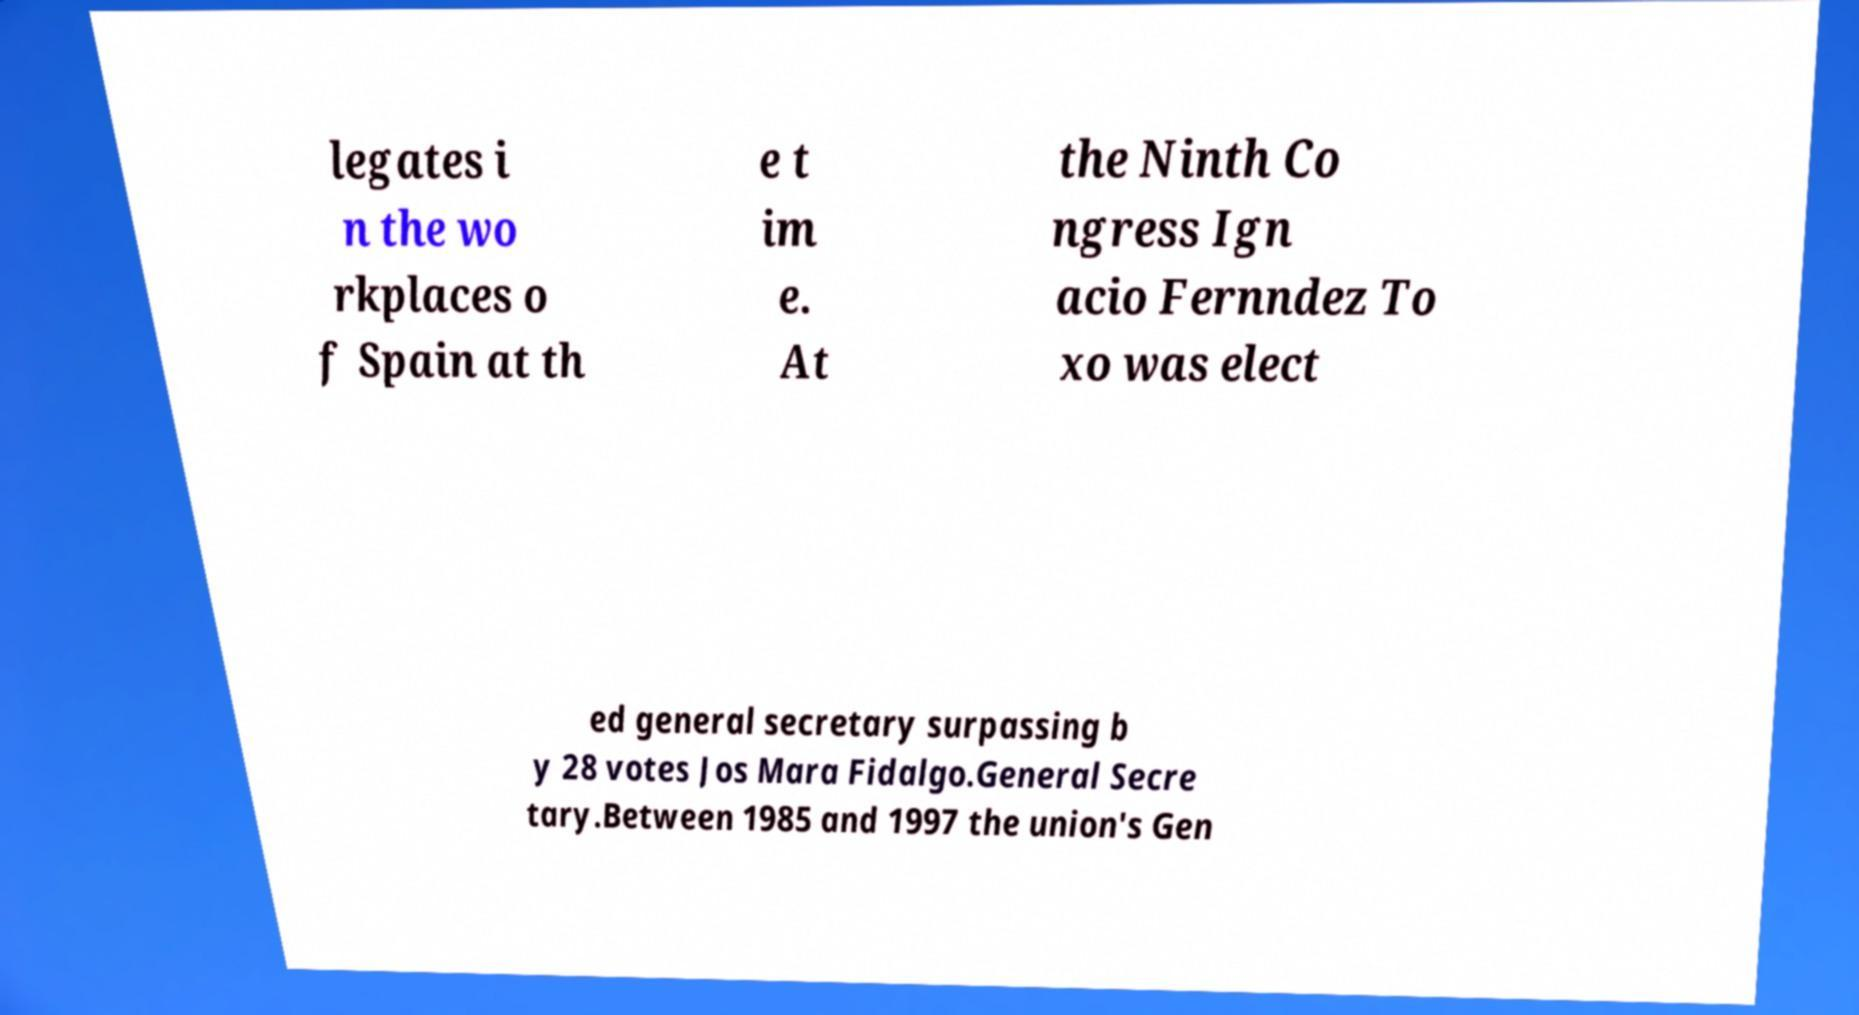Could you assist in decoding the text presented in this image and type it out clearly? legates i n the wo rkplaces o f Spain at th e t im e. At the Ninth Co ngress Ign acio Fernndez To xo was elect ed general secretary surpassing b y 28 votes Jos Mara Fidalgo.General Secre tary.Between 1985 and 1997 the union's Gen 